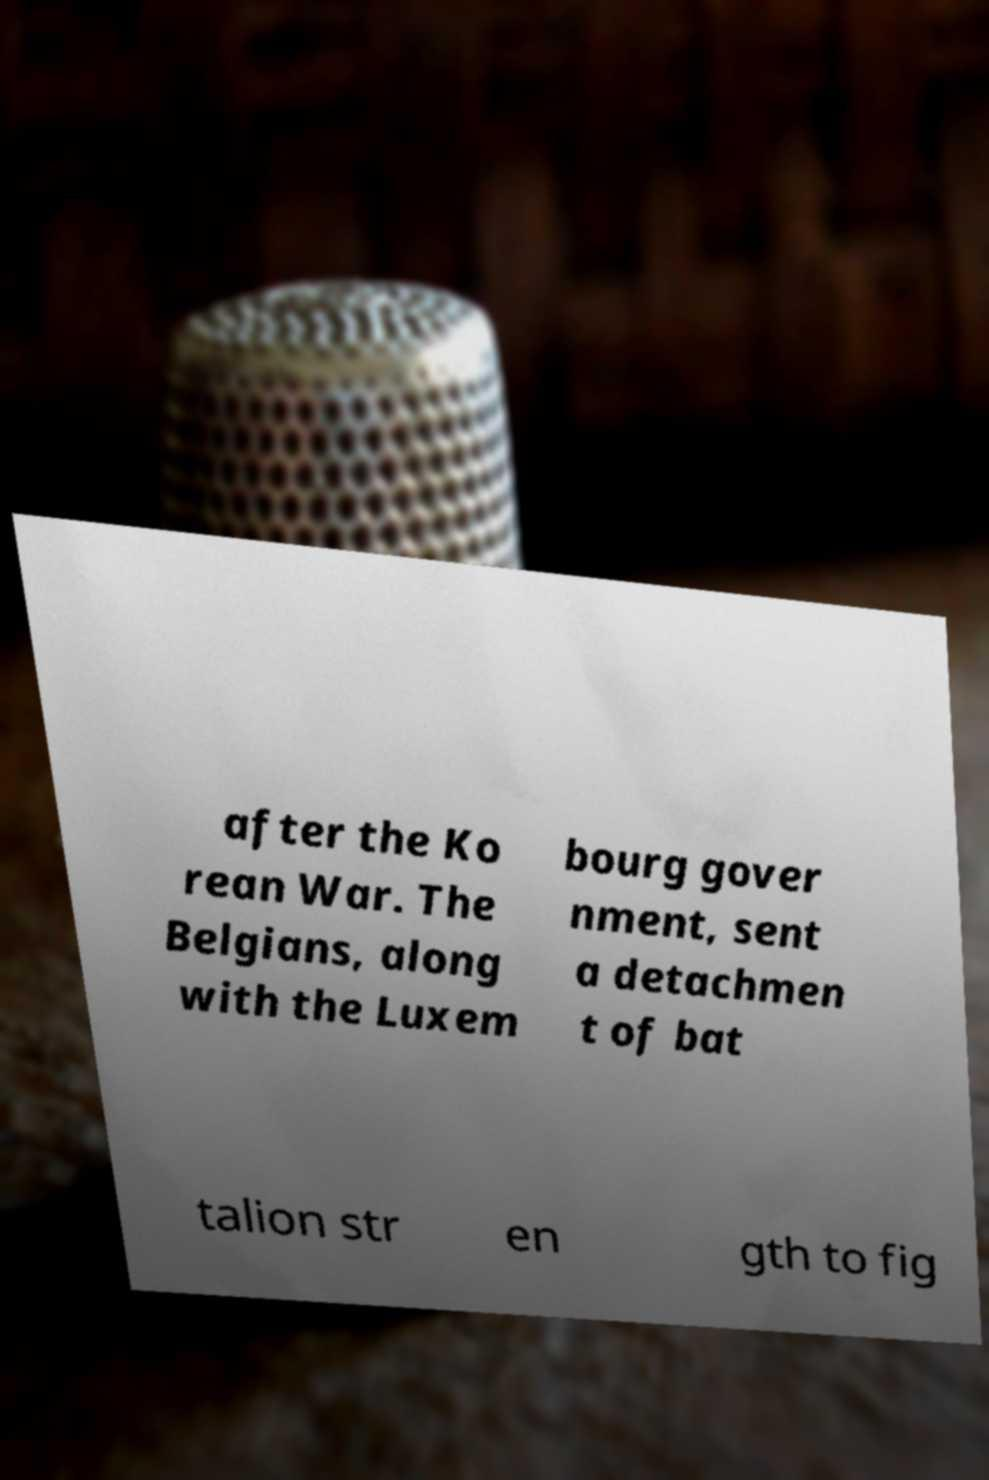Please read and relay the text visible in this image. What does it say? after the Ko rean War. The Belgians, along with the Luxem bourg gover nment, sent a detachmen t of bat talion str en gth to fig 